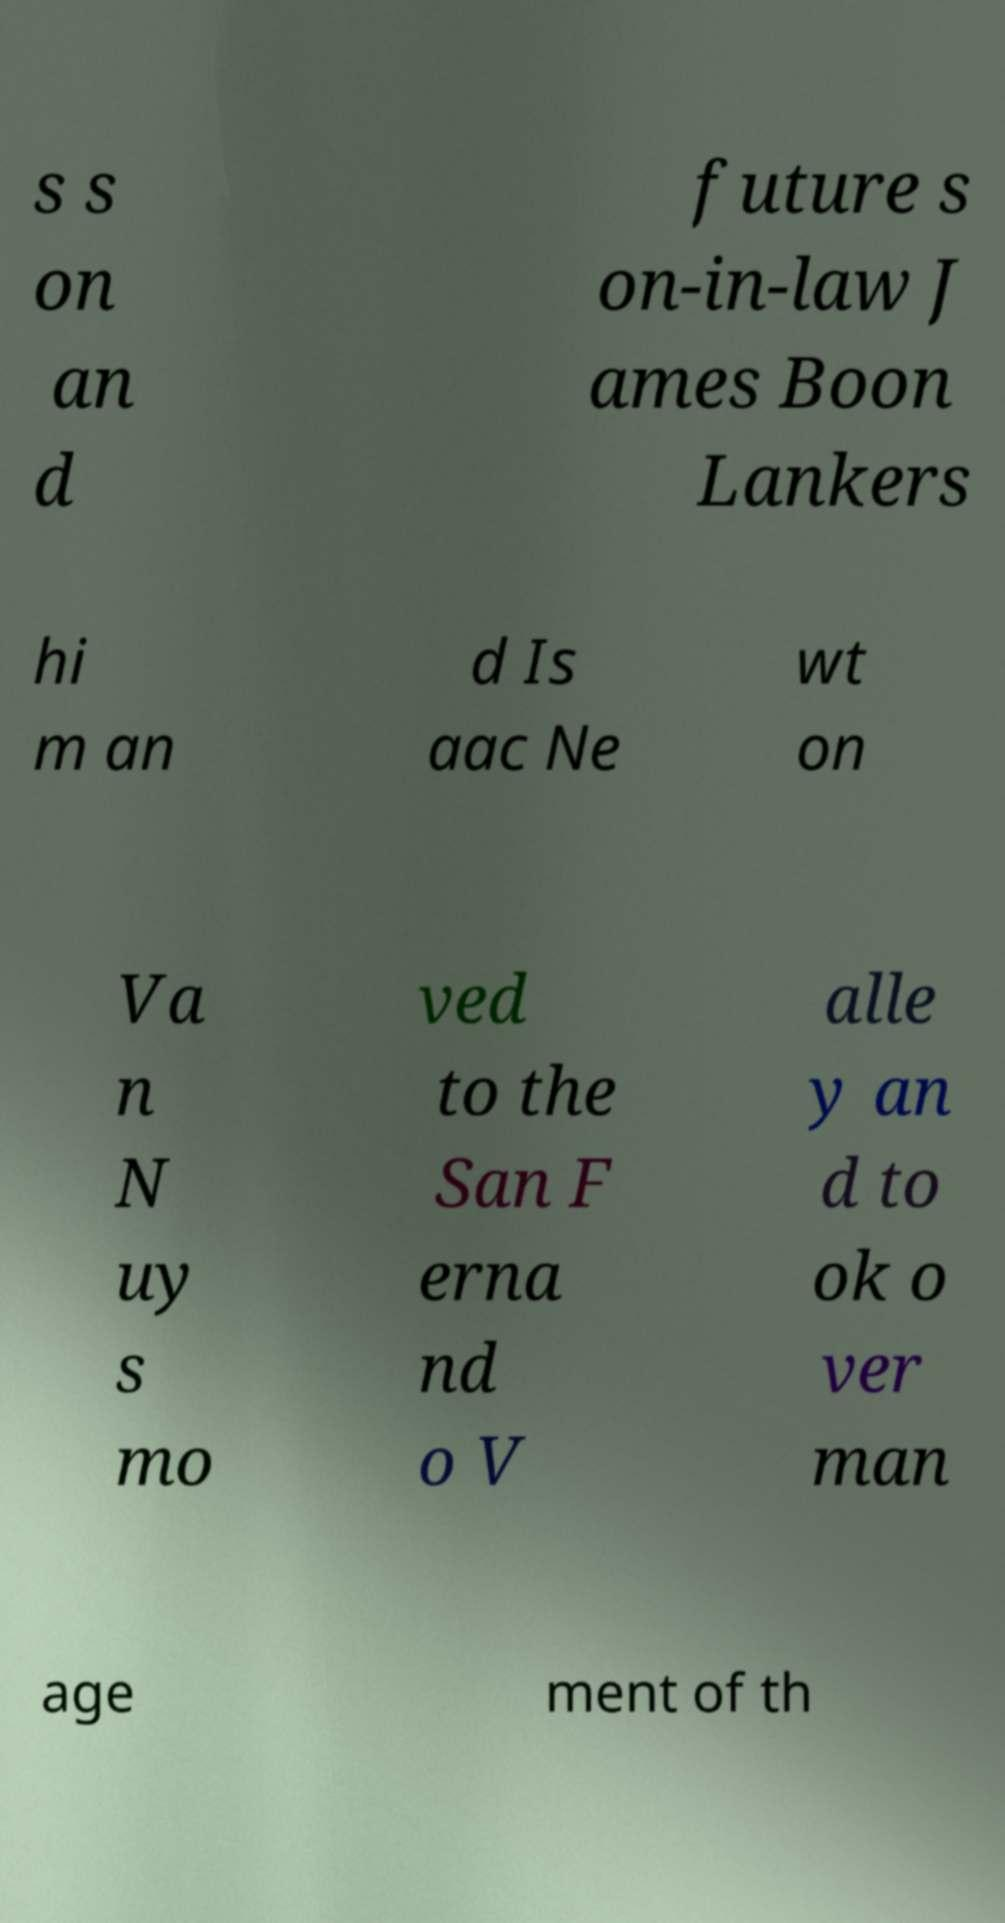I need the written content from this picture converted into text. Can you do that? s s on an d future s on-in-law J ames Boon Lankers hi m an d Is aac Ne wt on Va n N uy s mo ved to the San F erna nd o V alle y an d to ok o ver man age ment of th 